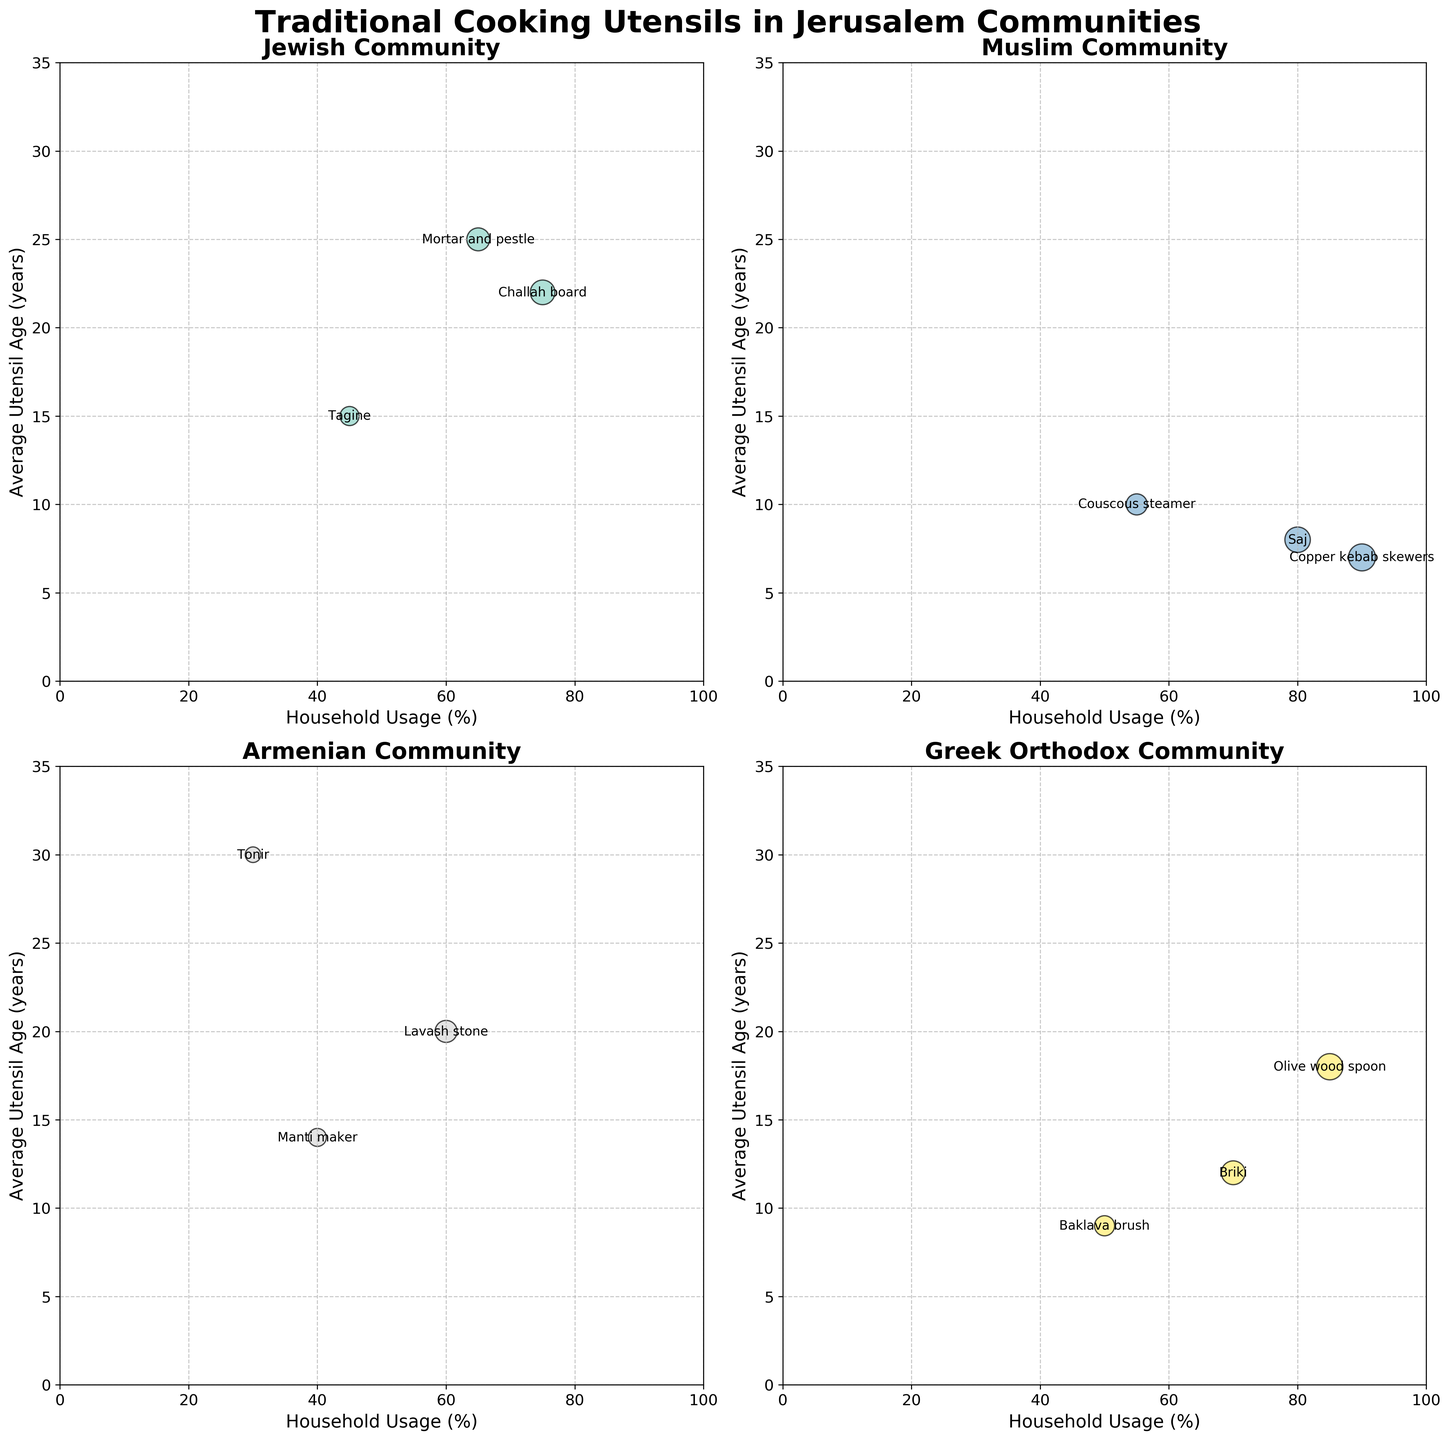Which community has the highest household usage of a single utensil? The Muslim community has the highest household usage with Copper kebab skewers at 90%, as indicated by the size and position of the bubble on the chart.
Answer: Muslim Which utensil in the Jewish community has the highest average age? The Mortar and pestle in the Jewish community is the oldest utensil with an average age of 25 years, shown by the higher position on the y-axis.
Answer: Mortar and pestle How does the household usage % for the Briki in the Greek Orthodox community compare to the Tagine in the Jewish community? Briki has a 70% household usage while Tagine has 45%, making Briki's usage higher.
Answer: Briki's usage is higher Which community has the most evenly distributed ages of their utensils? The Armenian community displays a wide range of utensil ages (14 to 30 years), indicating a more balanced distribution compared to others.
Answer: Armenian What is the average household usage of utensils in the Armenian community? Household usage is (60% + 30% + 40%) / 3 = 43.33%. The values are added and then divided by the number of utensils.
Answer: 43.33% Which utensil among all the communities has the youngest average age? The Copper kebab skewers in the Muslim community are the youngest with an average age of 7 years, represented by the lower position on the y-axis.
Answer: Copper kebab skewers What's the difference in average utensil age between the Tonir and the Baklava brush? Tonir has an average age of 30 years, and Baklava brush has 9 years, so the difference is 30 - 9 = 21 years.
Answer: 21 years Are the majority of the utensils in the Greek Orthodox community above or below 10 years of average age? Two of the three utensils (Briki at 12 years, Olive wood spoon at 18 years) are above 10 years of age, indicating the majority are above.
Answer: Above Does the Saj in the Muslim community have a higher average utensil age than the Baklava brush in the Greek Orthodox community? The average age of Saj is 8 years, which is less than the 9 years of the Baklava brush.
Answer: No Which Jewish utensil has the highest household usage and what is that percentage? The Challah board in the Jewish community has the highest household usage at 75%, indicated by the largest bubble.
Answer: Challah board, 75% 